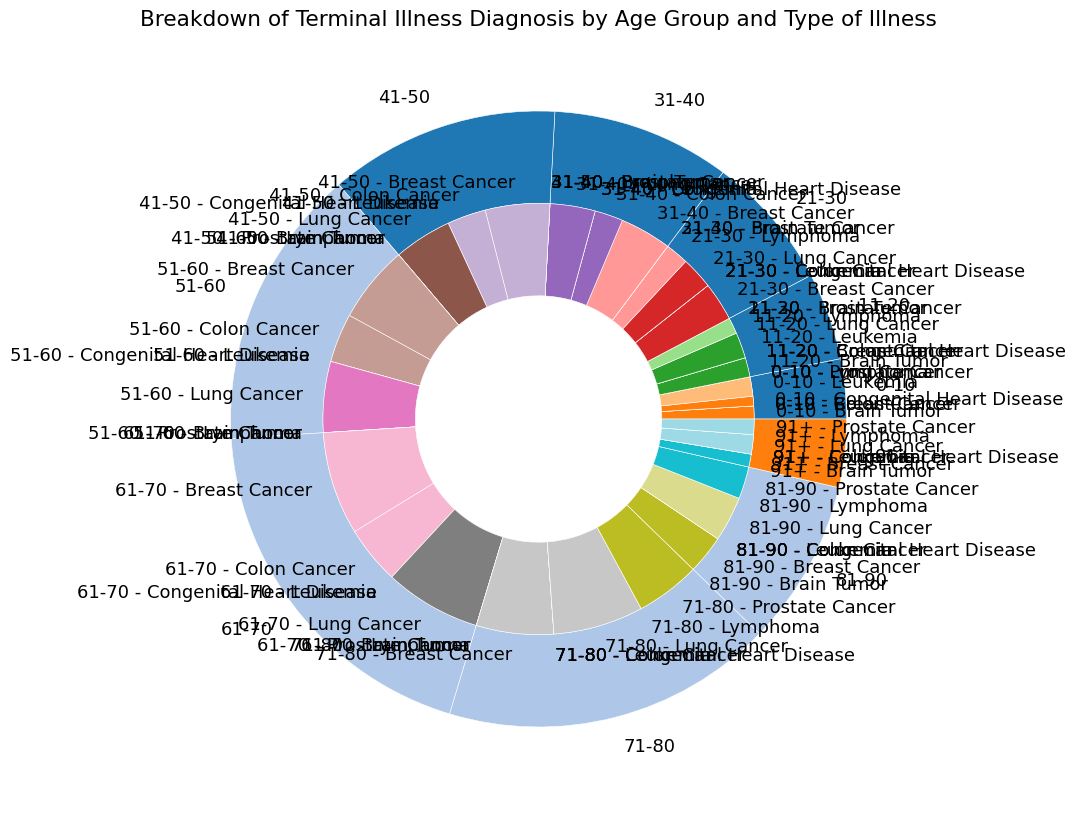What is the most common illness in the 11-20 age group? First, look at the slices in the inner pie chart corresponding to the 11-20 age group, then identify which illness has the largest section.
Answer: Leukemia Which age group has the highest total count of diagnosed terminal illnesses? Look at the outer pie chart and find the wedge that occupies the largest area.
Answer: 61-70 Compare the counts of Leukemia in the 0-10 age group and Lymphoma in the 21-30 age group. Which one is larger? Focus on the inner slices of the 0-10 group for Leukemia and the 21-30 group for Lymphoma. Compare their sizes.
Answer: Lymphoma in 21-30 How does the count of Breast Cancer cases in the 31-40 age group compare to the count in the 51-60 age group? Examine the inner slices for Breast Cancer in both the 31-40 and 51-60 age groups and compare their visual sizes.
Answer: 51-60 is larger What is the Prostate Cancer count in the 81-90 age group relative to the 71-80 age group? Compare the inner pie slices for Prostate Cancer in the 81-90 and 71-80 age groups.
Answer: 71-80 is larger In which age group is Lung Cancer more prevalent: 41-50 or 51-60? Compare the inner slices for Lung Cancer in the 41-50 and 51-60 age groups.
Answer: 51-60 Calculate the total count of Breast Cancer cases for the age groups 71-80 and 91+. Sum the counts from the inner slices of Breast Cancer for the 71-80 and 91+ age groups (600 + 100).
Answer: 700 Compare the total counts of illnesses in age groups 21-30 and 31-40. Which group has a higher total? Add up the counts of all illnesses from the inner slices in the 21-30 and 31-40 age groups and compare the sums.
Answer: 31-40 Which illness has the smallest total count across all age groups? Identify the illness type with the smallest accumulated slice width across all inner pie sections.
Answer: Congenital Heart Disease 